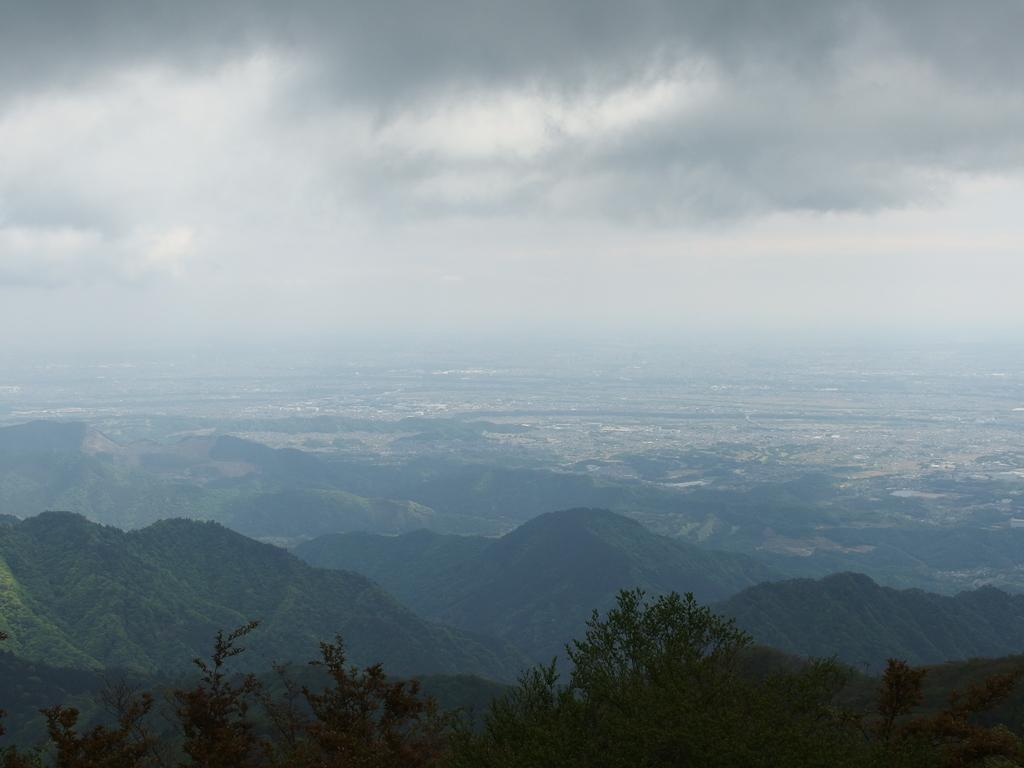What can be seen in the sky in the image? The sky with clouds is visible in the image. What is visible at the bottom of the image? There is ground visible in the image. What type of landform can be seen in the image? There are hills in the image. What type of vegetation is present in the image? Trees are present in the image. What type of beam is holding up the trees in the image? There is no beam present in the image; the trees are standing on their own. What mineral can be found in the quartz rocks in the image? There are no quartz rocks present in the image. 